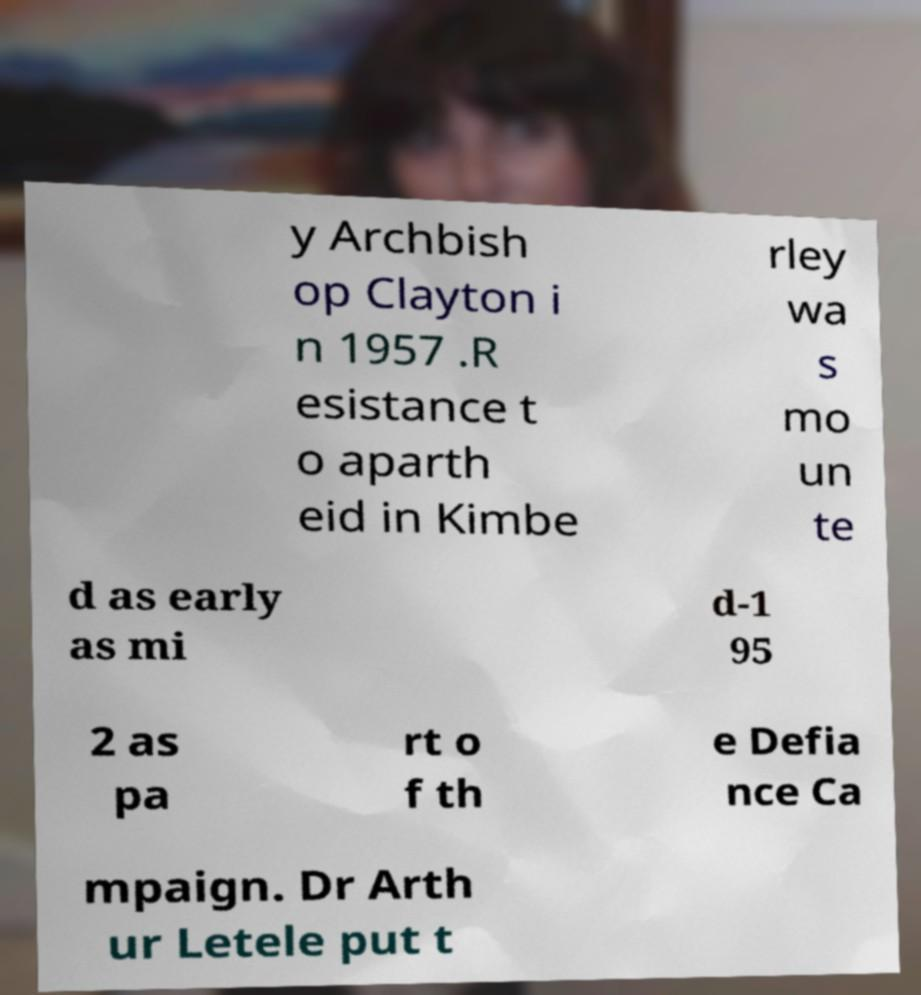There's text embedded in this image that I need extracted. Can you transcribe it verbatim? y Archbish op Clayton i n 1957 .R esistance t o aparth eid in Kimbe rley wa s mo un te d as early as mi d-1 95 2 as pa rt o f th e Defia nce Ca mpaign. Dr Arth ur Letele put t 